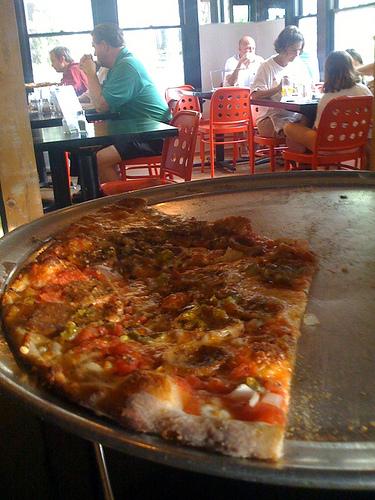How many holes are in the back of one chair?
Be succinct. 12. Are they eating in a restaurant?
Answer briefly. Yes. Has any of the pizza been eaten?
Give a very brief answer. Yes. 